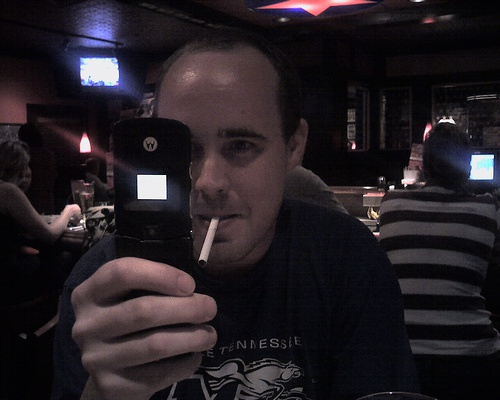Describe the objects in this image and their specific colors. I can see people in black and gray tones, people in black tones, cell phone in black, white, and gray tones, people in black, gray, darkgray, and lightpink tones, and tv in black, white, navy, and blue tones in this image. 